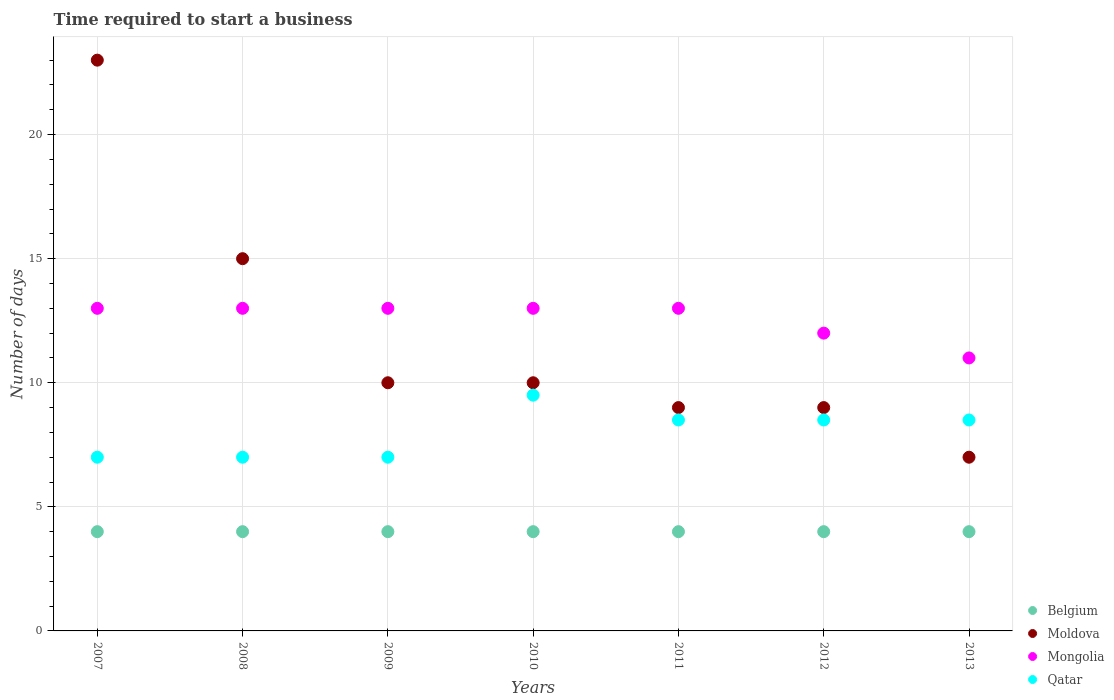How many different coloured dotlines are there?
Your answer should be very brief. 4. Is the number of dotlines equal to the number of legend labels?
Offer a terse response. Yes. What is the number of days required to start a business in Belgium in 2012?
Your answer should be very brief. 4. Across all years, what is the maximum number of days required to start a business in Mongolia?
Ensure brevity in your answer.  13. Across all years, what is the minimum number of days required to start a business in Moldova?
Offer a terse response. 7. What is the total number of days required to start a business in Mongolia in the graph?
Provide a short and direct response. 88. What is the difference between the number of days required to start a business in Mongolia in 2008 and that in 2012?
Provide a short and direct response. 1. What is the average number of days required to start a business in Mongolia per year?
Provide a succinct answer. 12.57. In the year 2009, what is the difference between the number of days required to start a business in Qatar and number of days required to start a business in Moldova?
Your response must be concise. -3. In how many years, is the number of days required to start a business in Mongolia greater than 18 days?
Your answer should be very brief. 0. Is the difference between the number of days required to start a business in Qatar in 2007 and 2011 greater than the difference between the number of days required to start a business in Moldova in 2007 and 2011?
Offer a very short reply. No. What is the difference between the highest and the lowest number of days required to start a business in Qatar?
Offer a very short reply. 2.5. In how many years, is the number of days required to start a business in Mongolia greater than the average number of days required to start a business in Mongolia taken over all years?
Provide a succinct answer. 5. Is it the case that in every year, the sum of the number of days required to start a business in Mongolia and number of days required to start a business in Moldova  is greater than the number of days required to start a business in Qatar?
Ensure brevity in your answer.  Yes. Does the number of days required to start a business in Moldova monotonically increase over the years?
Provide a short and direct response. No. Is the number of days required to start a business in Mongolia strictly less than the number of days required to start a business in Belgium over the years?
Provide a succinct answer. No. How many dotlines are there?
Make the answer very short. 4. How many years are there in the graph?
Give a very brief answer. 7. What is the difference between two consecutive major ticks on the Y-axis?
Make the answer very short. 5. Does the graph contain grids?
Offer a terse response. Yes. How many legend labels are there?
Offer a very short reply. 4. What is the title of the graph?
Keep it short and to the point. Time required to start a business. What is the label or title of the X-axis?
Your answer should be very brief. Years. What is the label or title of the Y-axis?
Provide a succinct answer. Number of days. What is the Number of days of Belgium in 2007?
Your response must be concise. 4. What is the Number of days in Moldova in 2007?
Your answer should be very brief. 23. What is the Number of days in Belgium in 2008?
Keep it short and to the point. 4. What is the Number of days of Belgium in 2009?
Offer a terse response. 4. What is the Number of days of Qatar in 2009?
Your answer should be very brief. 7. What is the Number of days of Moldova in 2010?
Provide a short and direct response. 10. What is the Number of days of Mongolia in 2010?
Offer a terse response. 13. What is the Number of days of Qatar in 2010?
Your answer should be compact. 9.5. What is the Number of days of Belgium in 2011?
Ensure brevity in your answer.  4. What is the Number of days in Mongolia in 2011?
Offer a terse response. 13. What is the Number of days in Moldova in 2012?
Your answer should be compact. 9. What is the Number of days of Mongolia in 2012?
Ensure brevity in your answer.  12. What is the Number of days in Belgium in 2013?
Make the answer very short. 4. What is the Number of days of Mongolia in 2013?
Ensure brevity in your answer.  11. What is the Number of days in Qatar in 2013?
Offer a very short reply. 8.5. Across all years, what is the maximum Number of days in Moldova?
Your response must be concise. 23. Across all years, what is the maximum Number of days in Qatar?
Give a very brief answer. 9.5. Across all years, what is the minimum Number of days of Belgium?
Ensure brevity in your answer.  4. Across all years, what is the minimum Number of days of Moldova?
Your response must be concise. 7. Across all years, what is the minimum Number of days in Mongolia?
Offer a very short reply. 11. What is the total Number of days in Belgium in the graph?
Keep it short and to the point. 28. What is the total Number of days of Moldova in the graph?
Ensure brevity in your answer.  83. What is the total Number of days in Mongolia in the graph?
Make the answer very short. 88. What is the total Number of days in Qatar in the graph?
Keep it short and to the point. 56. What is the difference between the Number of days of Mongolia in 2007 and that in 2008?
Ensure brevity in your answer.  0. What is the difference between the Number of days of Qatar in 2007 and that in 2008?
Your response must be concise. 0. What is the difference between the Number of days of Belgium in 2007 and that in 2009?
Provide a short and direct response. 0. What is the difference between the Number of days in Qatar in 2007 and that in 2009?
Ensure brevity in your answer.  0. What is the difference between the Number of days of Moldova in 2007 and that in 2011?
Your response must be concise. 14. What is the difference between the Number of days of Qatar in 2007 and that in 2011?
Provide a succinct answer. -1.5. What is the difference between the Number of days in Moldova in 2007 and that in 2012?
Your answer should be very brief. 14. What is the difference between the Number of days in Moldova in 2007 and that in 2013?
Give a very brief answer. 16. What is the difference between the Number of days in Belgium in 2008 and that in 2009?
Provide a succinct answer. 0. What is the difference between the Number of days in Mongolia in 2008 and that in 2009?
Make the answer very short. 0. What is the difference between the Number of days in Belgium in 2008 and that in 2010?
Keep it short and to the point. 0. What is the difference between the Number of days in Mongolia in 2008 and that in 2010?
Give a very brief answer. 0. What is the difference between the Number of days in Belgium in 2008 and that in 2012?
Your answer should be very brief. 0. What is the difference between the Number of days of Mongolia in 2008 and that in 2012?
Provide a short and direct response. 1. What is the difference between the Number of days of Moldova in 2008 and that in 2013?
Make the answer very short. 8. What is the difference between the Number of days in Belgium in 2009 and that in 2010?
Make the answer very short. 0. What is the difference between the Number of days of Moldova in 2009 and that in 2010?
Your response must be concise. 0. What is the difference between the Number of days in Mongolia in 2009 and that in 2011?
Your answer should be compact. 0. What is the difference between the Number of days in Qatar in 2009 and that in 2011?
Ensure brevity in your answer.  -1.5. What is the difference between the Number of days in Belgium in 2009 and that in 2013?
Provide a succinct answer. 0. What is the difference between the Number of days in Moldova in 2009 and that in 2013?
Give a very brief answer. 3. What is the difference between the Number of days of Moldova in 2010 and that in 2011?
Provide a succinct answer. 1. What is the difference between the Number of days in Belgium in 2010 and that in 2012?
Offer a terse response. 0. What is the difference between the Number of days in Moldova in 2010 and that in 2012?
Keep it short and to the point. 1. What is the difference between the Number of days of Qatar in 2010 and that in 2012?
Your answer should be very brief. 1. What is the difference between the Number of days in Belgium in 2010 and that in 2013?
Ensure brevity in your answer.  0. What is the difference between the Number of days of Moldova in 2010 and that in 2013?
Your answer should be compact. 3. What is the difference between the Number of days in Mongolia in 2010 and that in 2013?
Offer a very short reply. 2. What is the difference between the Number of days of Belgium in 2011 and that in 2012?
Your answer should be very brief. 0. What is the difference between the Number of days of Belgium in 2011 and that in 2013?
Keep it short and to the point. 0. What is the difference between the Number of days in Moldova in 2011 and that in 2013?
Keep it short and to the point. 2. What is the difference between the Number of days in Mongolia in 2011 and that in 2013?
Offer a very short reply. 2. What is the difference between the Number of days in Qatar in 2011 and that in 2013?
Make the answer very short. 0. What is the difference between the Number of days of Moldova in 2012 and that in 2013?
Your response must be concise. 2. What is the difference between the Number of days in Mongolia in 2012 and that in 2013?
Offer a very short reply. 1. What is the difference between the Number of days in Qatar in 2012 and that in 2013?
Offer a very short reply. 0. What is the difference between the Number of days in Belgium in 2007 and the Number of days in Mongolia in 2008?
Ensure brevity in your answer.  -9. What is the difference between the Number of days in Belgium in 2007 and the Number of days in Qatar in 2008?
Ensure brevity in your answer.  -3. What is the difference between the Number of days of Moldova in 2007 and the Number of days of Qatar in 2008?
Offer a terse response. 16. What is the difference between the Number of days in Mongolia in 2007 and the Number of days in Qatar in 2008?
Make the answer very short. 6. What is the difference between the Number of days of Belgium in 2007 and the Number of days of Moldova in 2009?
Keep it short and to the point. -6. What is the difference between the Number of days in Belgium in 2007 and the Number of days in Qatar in 2009?
Your answer should be compact. -3. What is the difference between the Number of days in Moldova in 2007 and the Number of days in Mongolia in 2009?
Ensure brevity in your answer.  10. What is the difference between the Number of days in Mongolia in 2007 and the Number of days in Qatar in 2009?
Make the answer very short. 6. What is the difference between the Number of days in Belgium in 2007 and the Number of days in Moldova in 2010?
Provide a short and direct response. -6. What is the difference between the Number of days in Belgium in 2007 and the Number of days in Mongolia in 2010?
Your answer should be compact. -9. What is the difference between the Number of days of Moldova in 2007 and the Number of days of Mongolia in 2010?
Your answer should be compact. 10. What is the difference between the Number of days of Mongolia in 2007 and the Number of days of Qatar in 2010?
Provide a succinct answer. 3.5. What is the difference between the Number of days of Belgium in 2007 and the Number of days of Qatar in 2011?
Ensure brevity in your answer.  -4.5. What is the difference between the Number of days in Moldova in 2007 and the Number of days in Mongolia in 2011?
Keep it short and to the point. 10. What is the difference between the Number of days in Belgium in 2007 and the Number of days in Mongolia in 2012?
Offer a terse response. -8. What is the difference between the Number of days in Belgium in 2007 and the Number of days in Qatar in 2012?
Offer a terse response. -4.5. What is the difference between the Number of days of Moldova in 2007 and the Number of days of Mongolia in 2012?
Your response must be concise. 11. What is the difference between the Number of days of Mongolia in 2007 and the Number of days of Qatar in 2012?
Your answer should be compact. 4.5. What is the difference between the Number of days of Belgium in 2007 and the Number of days of Qatar in 2013?
Your response must be concise. -4.5. What is the difference between the Number of days of Moldova in 2007 and the Number of days of Mongolia in 2013?
Ensure brevity in your answer.  12. What is the difference between the Number of days in Mongolia in 2007 and the Number of days in Qatar in 2013?
Keep it short and to the point. 4.5. What is the difference between the Number of days in Belgium in 2008 and the Number of days in Qatar in 2009?
Your answer should be very brief. -3. What is the difference between the Number of days in Moldova in 2008 and the Number of days in Qatar in 2009?
Offer a very short reply. 8. What is the difference between the Number of days in Mongolia in 2008 and the Number of days in Qatar in 2009?
Give a very brief answer. 6. What is the difference between the Number of days of Belgium in 2008 and the Number of days of Mongolia in 2010?
Provide a succinct answer. -9. What is the difference between the Number of days in Belgium in 2008 and the Number of days in Qatar in 2010?
Your answer should be compact. -5.5. What is the difference between the Number of days of Moldova in 2008 and the Number of days of Qatar in 2010?
Offer a terse response. 5.5. What is the difference between the Number of days of Mongolia in 2008 and the Number of days of Qatar in 2010?
Ensure brevity in your answer.  3.5. What is the difference between the Number of days in Belgium in 2008 and the Number of days in Moldova in 2011?
Provide a succinct answer. -5. What is the difference between the Number of days of Moldova in 2008 and the Number of days of Mongolia in 2011?
Provide a succinct answer. 2. What is the difference between the Number of days in Moldova in 2008 and the Number of days in Qatar in 2011?
Give a very brief answer. 6.5. What is the difference between the Number of days in Mongolia in 2008 and the Number of days in Qatar in 2011?
Your response must be concise. 4.5. What is the difference between the Number of days in Belgium in 2008 and the Number of days in Mongolia in 2012?
Your answer should be compact. -8. What is the difference between the Number of days in Mongolia in 2008 and the Number of days in Qatar in 2012?
Keep it short and to the point. 4.5. What is the difference between the Number of days of Belgium in 2008 and the Number of days of Moldova in 2013?
Make the answer very short. -3. What is the difference between the Number of days of Moldova in 2008 and the Number of days of Mongolia in 2013?
Provide a short and direct response. 4. What is the difference between the Number of days in Mongolia in 2008 and the Number of days in Qatar in 2013?
Make the answer very short. 4.5. What is the difference between the Number of days of Belgium in 2009 and the Number of days of Moldova in 2010?
Give a very brief answer. -6. What is the difference between the Number of days in Belgium in 2009 and the Number of days in Mongolia in 2010?
Your answer should be very brief. -9. What is the difference between the Number of days in Belgium in 2009 and the Number of days in Moldova in 2011?
Your answer should be very brief. -5. What is the difference between the Number of days in Belgium in 2009 and the Number of days in Mongolia in 2011?
Ensure brevity in your answer.  -9. What is the difference between the Number of days in Moldova in 2009 and the Number of days in Qatar in 2011?
Provide a succinct answer. 1.5. What is the difference between the Number of days in Mongolia in 2009 and the Number of days in Qatar in 2011?
Offer a very short reply. 4.5. What is the difference between the Number of days of Belgium in 2009 and the Number of days of Mongolia in 2012?
Ensure brevity in your answer.  -8. What is the difference between the Number of days of Belgium in 2009 and the Number of days of Qatar in 2012?
Offer a very short reply. -4.5. What is the difference between the Number of days in Mongolia in 2009 and the Number of days in Qatar in 2012?
Give a very brief answer. 4.5. What is the difference between the Number of days in Belgium in 2009 and the Number of days in Moldova in 2013?
Your answer should be compact. -3. What is the difference between the Number of days of Moldova in 2009 and the Number of days of Qatar in 2013?
Your response must be concise. 1.5. What is the difference between the Number of days of Mongolia in 2009 and the Number of days of Qatar in 2013?
Offer a very short reply. 4.5. What is the difference between the Number of days in Belgium in 2010 and the Number of days in Mongolia in 2011?
Ensure brevity in your answer.  -9. What is the difference between the Number of days of Belgium in 2010 and the Number of days of Qatar in 2011?
Offer a terse response. -4.5. What is the difference between the Number of days of Belgium in 2010 and the Number of days of Moldova in 2012?
Make the answer very short. -5. What is the difference between the Number of days of Moldova in 2010 and the Number of days of Mongolia in 2012?
Provide a short and direct response. -2. What is the difference between the Number of days of Mongolia in 2010 and the Number of days of Qatar in 2012?
Your answer should be very brief. 4.5. What is the difference between the Number of days in Belgium in 2010 and the Number of days in Mongolia in 2013?
Keep it short and to the point. -7. What is the difference between the Number of days of Belgium in 2010 and the Number of days of Qatar in 2013?
Provide a succinct answer. -4.5. What is the difference between the Number of days in Moldova in 2010 and the Number of days in Qatar in 2013?
Ensure brevity in your answer.  1.5. What is the difference between the Number of days in Belgium in 2011 and the Number of days in Moldova in 2012?
Offer a terse response. -5. What is the difference between the Number of days in Belgium in 2011 and the Number of days in Mongolia in 2012?
Ensure brevity in your answer.  -8. What is the difference between the Number of days in Mongolia in 2011 and the Number of days in Qatar in 2012?
Your response must be concise. 4.5. What is the difference between the Number of days of Belgium in 2011 and the Number of days of Mongolia in 2013?
Provide a succinct answer. -7. What is the difference between the Number of days of Moldova in 2011 and the Number of days of Qatar in 2013?
Your response must be concise. 0.5. What is the difference between the Number of days in Mongolia in 2011 and the Number of days in Qatar in 2013?
Your answer should be compact. 4.5. What is the difference between the Number of days of Belgium in 2012 and the Number of days of Mongolia in 2013?
Your response must be concise. -7. What is the difference between the Number of days of Moldova in 2012 and the Number of days of Mongolia in 2013?
Give a very brief answer. -2. What is the difference between the Number of days of Moldova in 2012 and the Number of days of Qatar in 2013?
Provide a short and direct response. 0.5. What is the average Number of days in Belgium per year?
Provide a short and direct response. 4. What is the average Number of days in Moldova per year?
Provide a short and direct response. 11.86. What is the average Number of days in Mongolia per year?
Provide a short and direct response. 12.57. In the year 2007, what is the difference between the Number of days in Belgium and Number of days in Moldova?
Your answer should be very brief. -19. In the year 2007, what is the difference between the Number of days of Belgium and Number of days of Mongolia?
Give a very brief answer. -9. In the year 2007, what is the difference between the Number of days of Belgium and Number of days of Qatar?
Ensure brevity in your answer.  -3. In the year 2008, what is the difference between the Number of days in Belgium and Number of days in Mongolia?
Keep it short and to the point. -9. In the year 2008, what is the difference between the Number of days of Belgium and Number of days of Qatar?
Ensure brevity in your answer.  -3. In the year 2008, what is the difference between the Number of days in Mongolia and Number of days in Qatar?
Your answer should be very brief. 6. In the year 2009, what is the difference between the Number of days of Belgium and Number of days of Moldova?
Give a very brief answer. -6. In the year 2009, what is the difference between the Number of days of Belgium and Number of days of Mongolia?
Offer a very short reply. -9. In the year 2009, what is the difference between the Number of days of Belgium and Number of days of Qatar?
Offer a terse response. -3. In the year 2009, what is the difference between the Number of days in Moldova and Number of days in Mongolia?
Offer a very short reply. -3. In the year 2009, what is the difference between the Number of days in Mongolia and Number of days in Qatar?
Offer a very short reply. 6. In the year 2010, what is the difference between the Number of days in Belgium and Number of days in Moldova?
Offer a very short reply. -6. In the year 2010, what is the difference between the Number of days of Belgium and Number of days of Mongolia?
Your answer should be very brief. -9. In the year 2010, what is the difference between the Number of days of Moldova and Number of days of Mongolia?
Offer a very short reply. -3. In the year 2010, what is the difference between the Number of days of Mongolia and Number of days of Qatar?
Ensure brevity in your answer.  3.5. In the year 2011, what is the difference between the Number of days of Belgium and Number of days of Moldova?
Provide a succinct answer. -5. In the year 2011, what is the difference between the Number of days in Belgium and Number of days in Mongolia?
Keep it short and to the point. -9. In the year 2011, what is the difference between the Number of days of Belgium and Number of days of Qatar?
Your answer should be very brief. -4.5. In the year 2012, what is the difference between the Number of days of Belgium and Number of days of Mongolia?
Your response must be concise. -8. In the year 2012, what is the difference between the Number of days of Moldova and Number of days of Mongolia?
Keep it short and to the point. -3. In the year 2012, what is the difference between the Number of days in Mongolia and Number of days in Qatar?
Your answer should be compact. 3.5. In the year 2013, what is the difference between the Number of days in Belgium and Number of days in Moldova?
Keep it short and to the point. -3. In the year 2013, what is the difference between the Number of days of Belgium and Number of days of Qatar?
Provide a succinct answer. -4.5. In the year 2013, what is the difference between the Number of days of Moldova and Number of days of Mongolia?
Offer a very short reply. -4. What is the ratio of the Number of days of Belgium in 2007 to that in 2008?
Provide a succinct answer. 1. What is the ratio of the Number of days of Moldova in 2007 to that in 2008?
Offer a very short reply. 1.53. What is the ratio of the Number of days of Belgium in 2007 to that in 2009?
Your answer should be very brief. 1. What is the ratio of the Number of days in Moldova in 2007 to that in 2009?
Your response must be concise. 2.3. What is the ratio of the Number of days of Mongolia in 2007 to that in 2010?
Your answer should be very brief. 1. What is the ratio of the Number of days in Qatar in 2007 to that in 2010?
Offer a terse response. 0.74. What is the ratio of the Number of days of Moldova in 2007 to that in 2011?
Ensure brevity in your answer.  2.56. What is the ratio of the Number of days of Mongolia in 2007 to that in 2011?
Ensure brevity in your answer.  1. What is the ratio of the Number of days in Qatar in 2007 to that in 2011?
Make the answer very short. 0.82. What is the ratio of the Number of days in Moldova in 2007 to that in 2012?
Your answer should be compact. 2.56. What is the ratio of the Number of days of Mongolia in 2007 to that in 2012?
Ensure brevity in your answer.  1.08. What is the ratio of the Number of days in Qatar in 2007 to that in 2012?
Keep it short and to the point. 0.82. What is the ratio of the Number of days in Belgium in 2007 to that in 2013?
Give a very brief answer. 1. What is the ratio of the Number of days of Moldova in 2007 to that in 2013?
Make the answer very short. 3.29. What is the ratio of the Number of days of Mongolia in 2007 to that in 2013?
Your answer should be very brief. 1.18. What is the ratio of the Number of days of Qatar in 2007 to that in 2013?
Offer a very short reply. 0.82. What is the ratio of the Number of days in Mongolia in 2008 to that in 2009?
Your answer should be compact. 1. What is the ratio of the Number of days of Mongolia in 2008 to that in 2010?
Your answer should be compact. 1. What is the ratio of the Number of days of Qatar in 2008 to that in 2010?
Make the answer very short. 0.74. What is the ratio of the Number of days of Mongolia in 2008 to that in 2011?
Your answer should be compact. 1. What is the ratio of the Number of days in Qatar in 2008 to that in 2011?
Provide a short and direct response. 0.82. What is the ratio of the Number of days of Moldova in 2008 to that in 2012?
Give a very brief answer. 1.67. What is the ratio of the Number of days of Mongolia in 2008 to that in 2012?
Offer a very short reply. 1.08. What is the ratio of the Number of days of Qatar in 2008 to that in 2012?
Make the answer very short. 0.82. What is the ratio of the Number of days in Belgium in 2008 to that in 2013?
Provide a short and direct response. 1. What is the ratio of the Number of days of Moldova in 2008 to that in 2013?
Offer a terse response. 2.14. What is the ratio of the Number of days in Mongolia in 2008 to that in 2013?
Offer a terse response. 1.18. What is the ratio of the Number of days in Qatar in 2008 to that in 2013?
Make the answer very short. 0.82. What is the ratio of the Number of days in Belgium in 2009 to that in 2010?
Offer a terse response. 1. What is the ratio of the Number of days of Qatar in 2009 to that in 2010?
Ensure brevity in your answer.  0.74. What is the ratio of the Number of days of Belgium in 2009 to that in 2011?
Offer a terse response. 1. What is the ratio of the Number of days of Moldova in 2009 to that in 2011?
Your answer should be very brief. 1.11. What is the ratio of the Number of days in Mongolia in 2009 to that in 2011?
Provide a short and direct response. 1. What is the ratio of the Number of days in Qatar in 2009 to that in 2011?
Your response must be concise. 0.82. What is the ratio of the Number of days in Qatar in 2009 to that in 2012?
Keep it short and to the point. 0.82. What is the ratio of the Number of days of Moldova in 2009 to that in 2013?
Your answer should be very brief. 1.43. What is the ratio of the Number of days of Mongolia in 2009 to that in 2013?
Offer a very short reply. 1.18. What is the ratio of the Number of days of Qatar in 2009 to that in 2013?
Provide a succinct answer. 0.82. What is the ratio of the Number of days in Qatar in 2010 to that in 2011?
Make the answer very short. 1.12. What is the ratio of the Number of days of Mongolia in 2010 to that in 2012?
Ensure brevity in your answer.  1.08. What is the ratio of the Number of days of Qatar in 2010 to that in 2012?
Provide a short and direct response. 1.12. What is the ratio of the Number of days of Moldova in 2010 to that in 2013?
Ensure brevity in your answer.  1.43. What is the ratio of the Number of days in Mongolia in 2010 to that in 2013?
Your response must be concise. 1.18. What is the ratio of the Number of days in Qatar in 2010 to that in 2013?
Give a very brief answer. 1.12. What is the ratio of the Number of days of Belgium in 2011 to that in 2012?
Give a very brief answer. 1. What is the ratio of the Number of days of Moldova in 2011 to that in 2012?
Your answer should be compact. 1. What is the ratio of the Number of days of Mongolia in 2011 to that in 2013?
Keep it short and to the point. 1.18. What is the ratio of the Number of days of Moldova in 2012 to that in 2013?
Ensure brevity in your answer.  1.29. What is the difference between the highest and the second highest Number of days in Moldova?
Ensure brevity in your answer.  8. What is the difference between the highest and the second highest Number of days in Mongolia?
Offer a very short reply. 0. What is the difference between the highest and the lowest Number of days in Belgium?
Provide a succinct answer. 0. What is the difference between the highest and the lowest Number of days of Moldova?
Provide a succinct answer. 16. What is the difference between the highest and the lowest Number of days of Qatar?
Offer a very short reply. 2.5. 